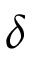<formula> <loc_0><loc_0><loc_500><loc_500>\delta</formula> 